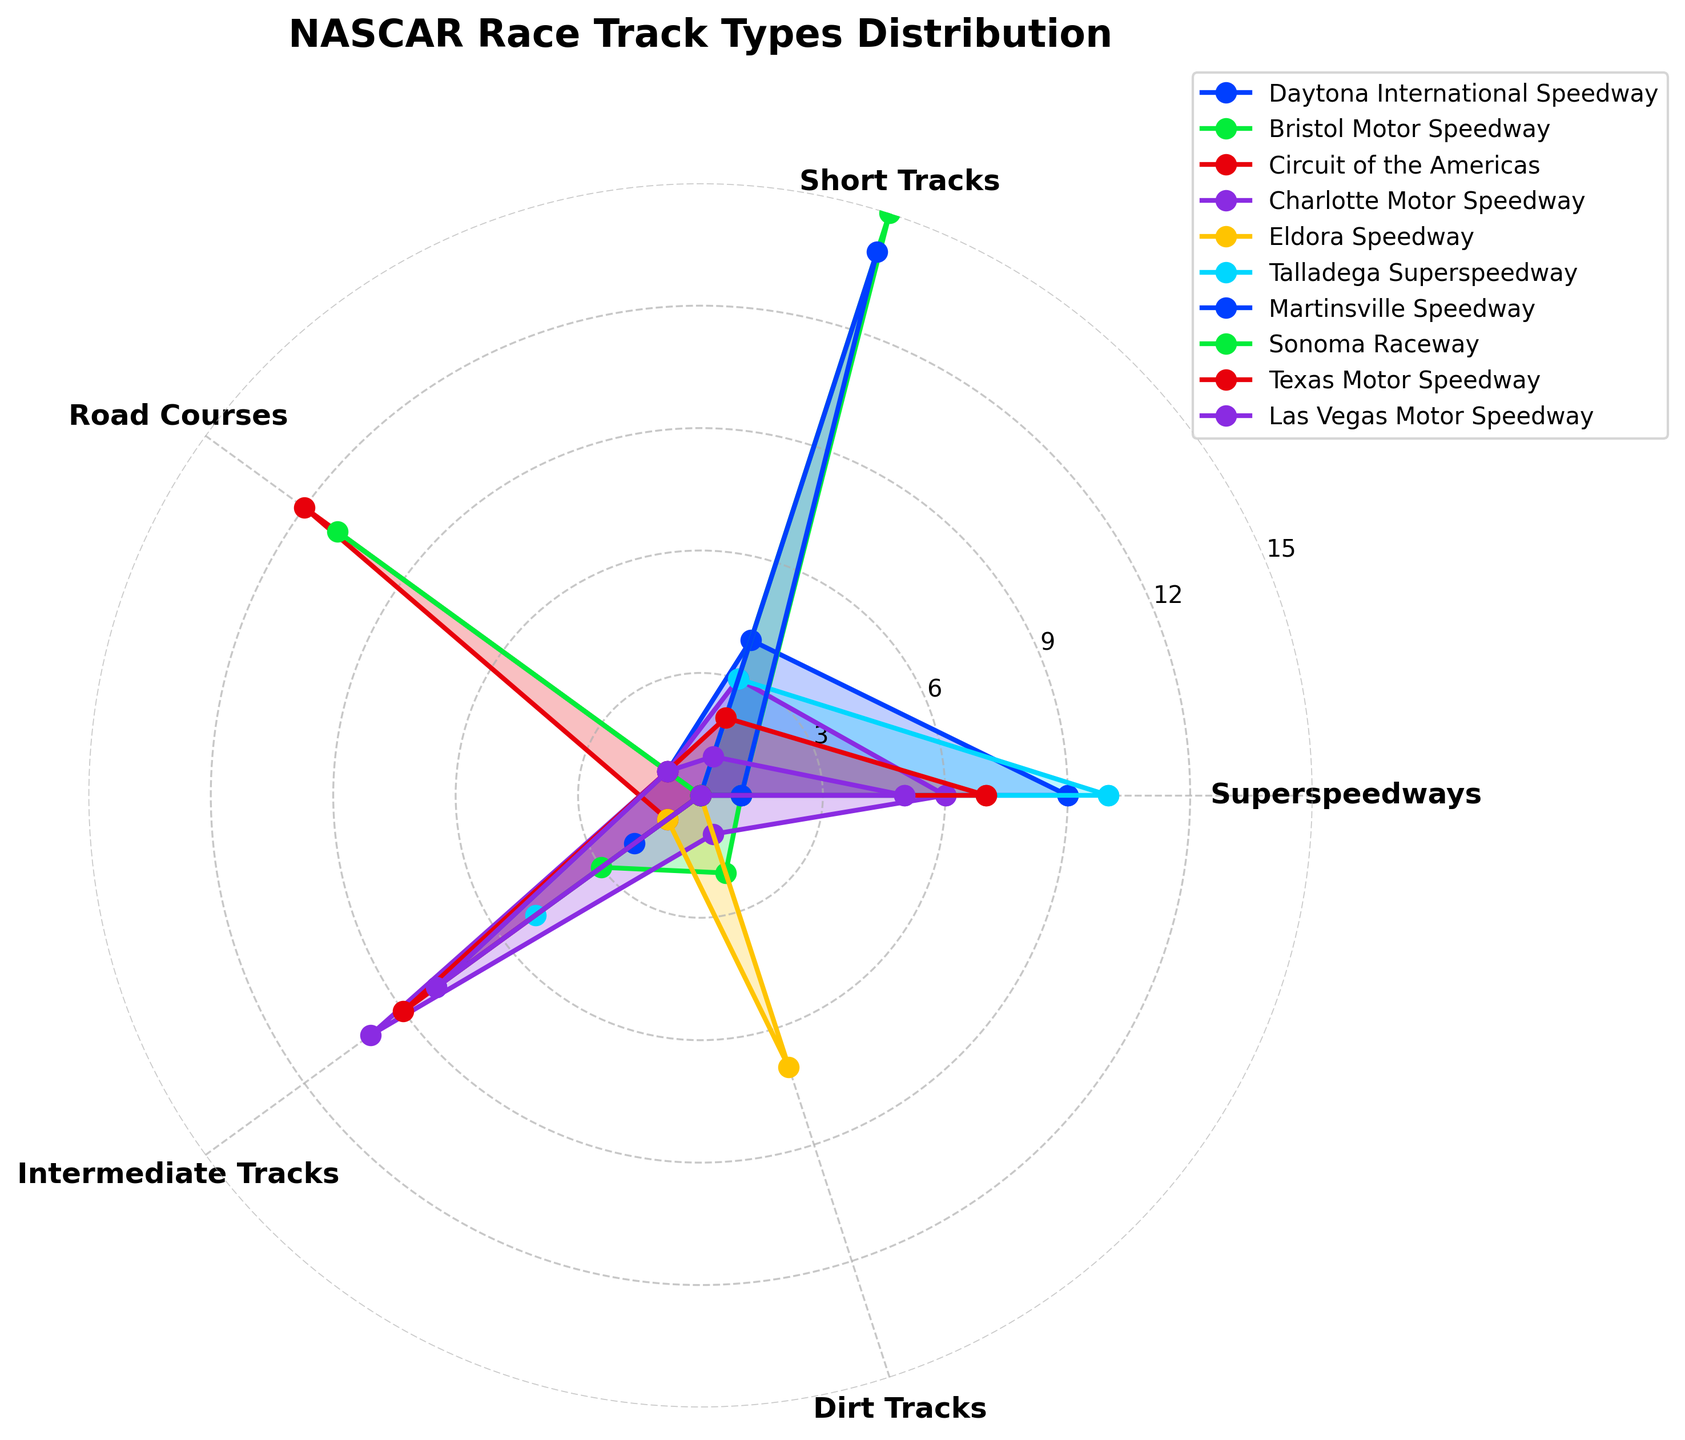What is the title of the radar chart? The title is located at the top of the chart and summarizes the data being represented.
Answer: NASCAR Race Track Types Distribution Which track has the highest value for Superspeedways? The Superspeedways category is represented by one of the axes; by examining the data points along this axis, we can identify the highest value.
Answer: Talladega Superspeedway How many types of race tracks are shown in the radar chart? The categories are indicated by the labels around the chart's perimeter. Counting these labels tells us the number of track types analyzed.
Answer: 5 Which track has the fewest Road Courses? The Road Courses category is one of the axes; examining the lengths of the corresponding lines and their values reveals the track with the fewest Road Courses.
Answer: Bristol Motor Speedway, Eldora Speedway, Martinsville Speedway, Talladega Superspeedway, Las Vegas Motor Speedway What is the average number of Dirt Tracks across all tracks? Sum the Dirt Tracks values from all tracks and divide by the number of tracks. (0+2+0+1+7+0+0+0+0+0) / 10 = 1
Answer: 1 Which track types dominate Bristol Motor Speedway? Look at the plot for Bristol Motor Speedway and observe the axes with the longest corresponding lines.
Answer: Short Tracks and Dirt Tracks Between Daytona International Speedway and Charlotte Motor Speedway, which has more Intermediate Tracks? Compare the values for Intermediate Tracks for both Daytona International Speedway and Charlotte Motor Speedway. 8 vs. 10.
Answer: Charlotte Motor Speedway How does the number of Road Courses at Circuit of the Americas compare to the other tracks? Observe the value for Road Courses at Circuit of the Americas and compare it to the values at the other tracks.
Answer: Circuit of the Americas has the most with a value of 12 Which track has equally distributed values across all categories? Examine the radar plot for equal lengths of lines extending from the center for any track.
Answer: None What's the sum of Superspeedways for Daytona International Speedway and Talladega Superspeedway? Add the values of Superspeedways for both tracks. 9 (Daytona) + 10 (Talladega) = 19
Answer: 19 